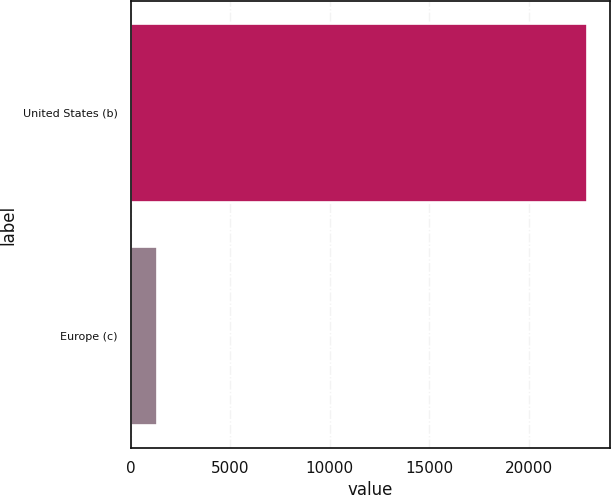Convert chart. <chart><loc_0><loc_0><loc_500><loc_500><bar_chart><fcel>United States (b)<fcel>Europe (c)<nl><fcel>22908<fcel>1317<nl></chart> 